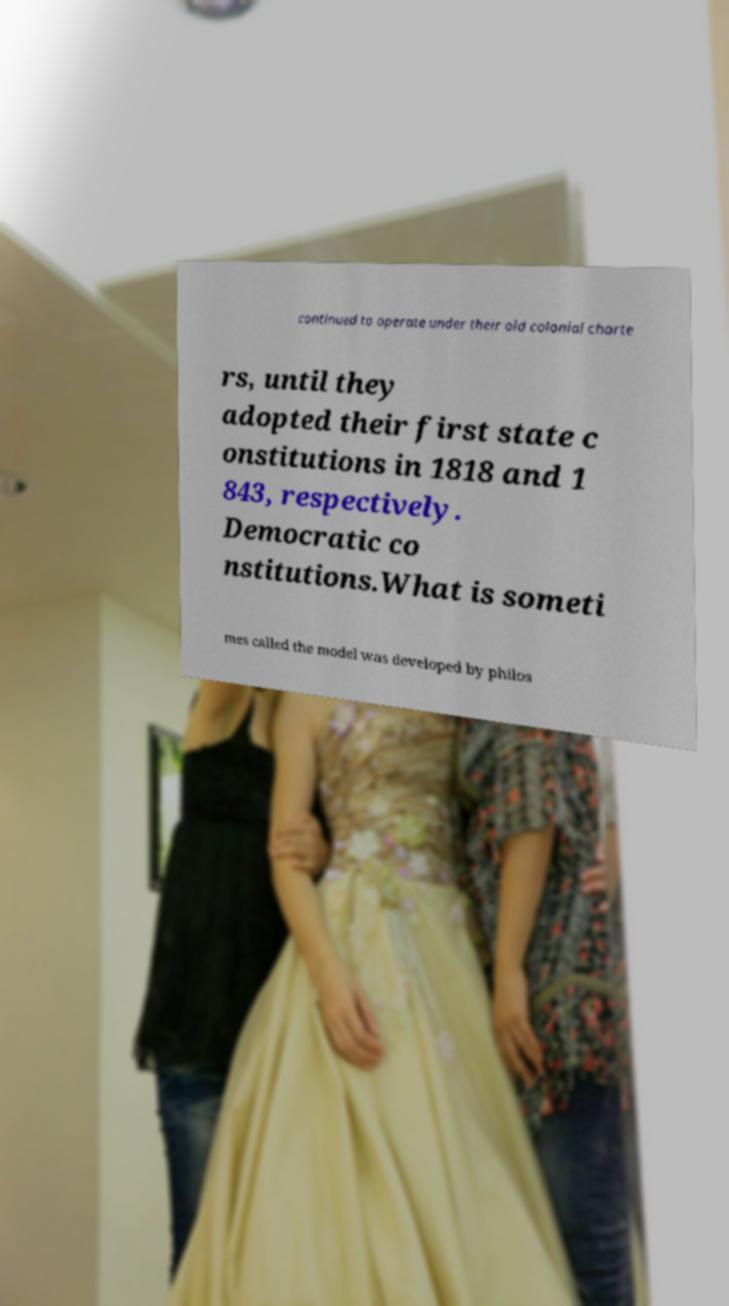Could you extract and type out the text from this image? continued to operate under their old colonial charte rs, until they adopted their first state c onstitutions in 1818 and 1 843, respectively. Democratic co nstitutions.What is someti mes called the model was developed by philos 